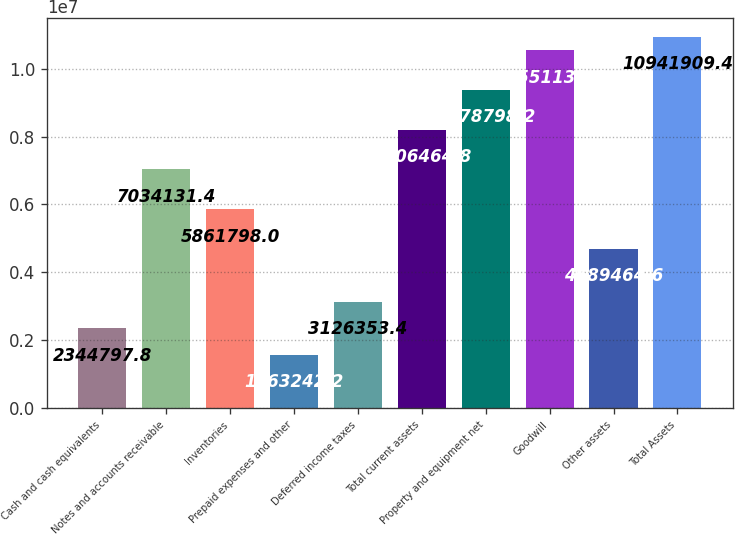Convert chart to OTSL. <chart><loc_0><loc_0><loc_500><loc_500><bar_chart><fcel>Cash and cash equivalents<fcel>Notes and accounts receivable<fcel>Inventories<fcel>Prepaid expenses and other<fcel>Deferred income taxes<fcel>Total current assets<fcel>Property and equipment net<fcel>Goodwill<fcel>Other assets<fcel>Total Assets<nl><fcel>2.3448e+06<fcel>7.03413e+06<fcel>5.8618e+06<fcel>1.56324e+06<fcel>3.12635e+06<fcel>8.20646e+06<fcel>9.3788e+06<fcel>1.05511e+07<fcel>4.68946e+06<fcel>1.09419e+07<nl></chart> 